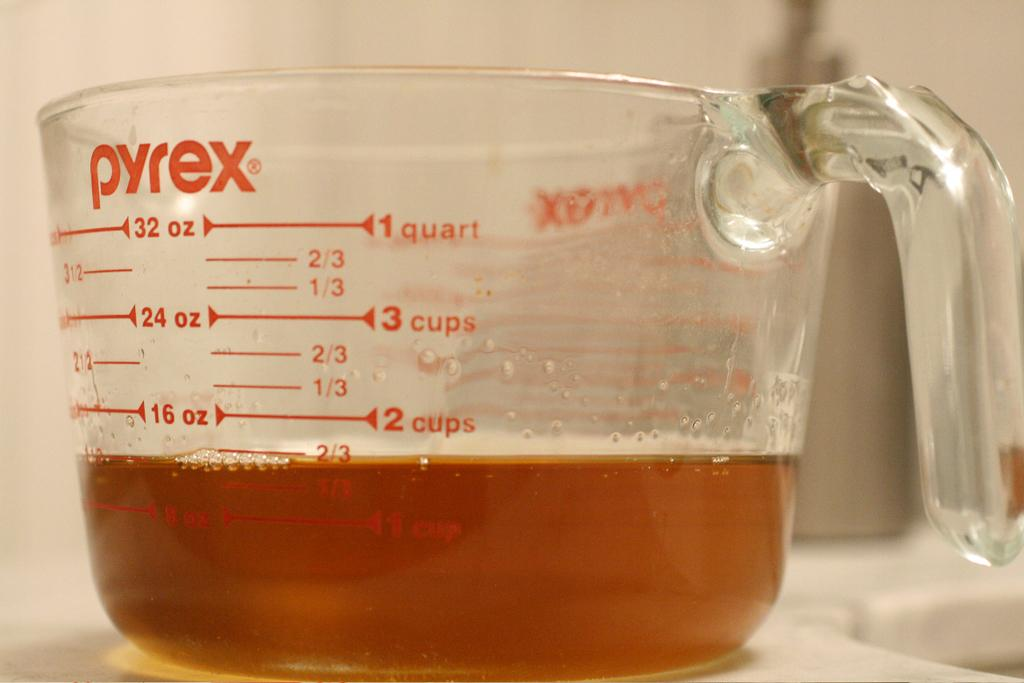<image>
Offer a succinct explanation of the picture presented. A clear glass Pyrex measuring cup with a brown liquid inside. 